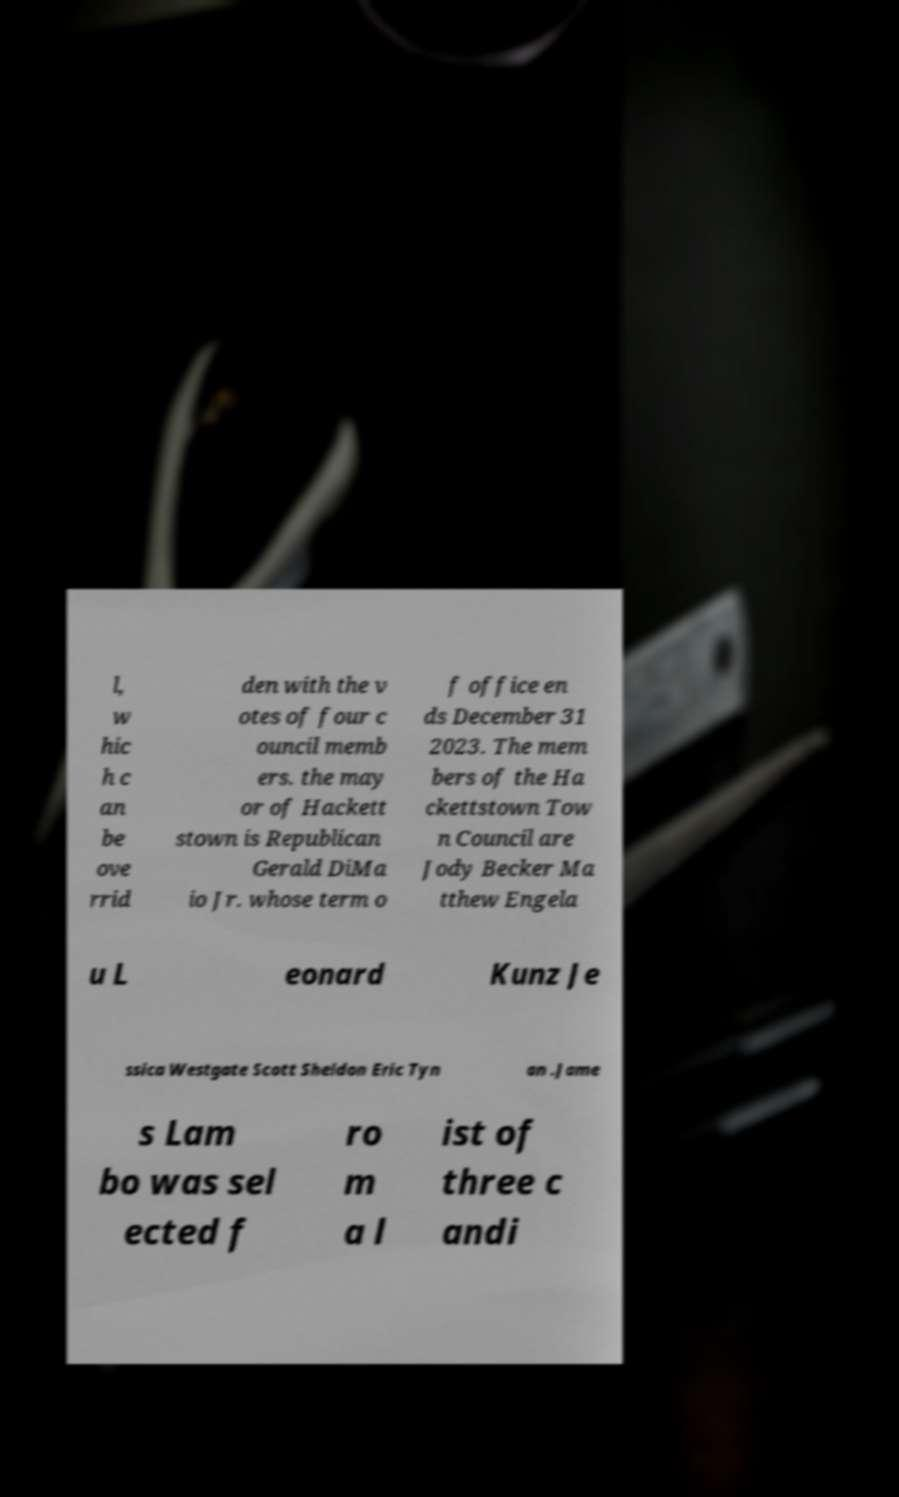Could you assist in decoding the text presented in this image and type it out clearly? l, w hic h c an be ove rrid den with the v otes of four c ouncil memb ers. the may or of Hackett stown is Republican Gerald DiMa io Jr. whose term o f office en ds December 31 2023. The mem bers of the Ha ckettstown Tow n Council are Jody Becker Ma tthew Engela u L eonard Kunz Je ssica Westgate Scott Sheldon Eric Tyn an .Jame s Lam bo was sel ected f ro m a l ist of three c andi 